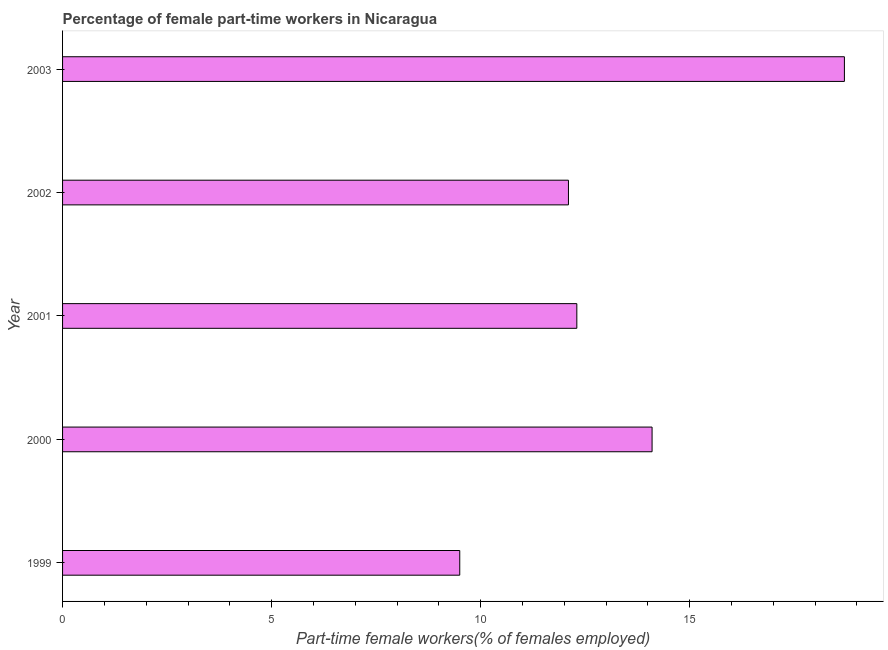Does the graph contain any zero values?
Your answer should be very brief. No. Does the graph contain grids?
Provide a succinct answer. No. What is the title of the graph?
Ensure brevity in your answer.  Percentage of female part-time workers in Nicaragua. What is the label or title of the X-axis?
Ensure brevity in your answer.  Part-time female workers(% of females employed). What is the label or title of the Y-axis?
Your answer should be compact. Year. What is the percentage of part-time female workers in 2000?
Your response must be concise. 14.1. Across all years, what is the maximum percentage of part-time female workers?
Offer a terse response. 18.7. Across all years, what is the minimum percentage of part-time female workers?
Your response must be concise. 9.5. What is the sum of the percentage of part-time female workers?
Offer a very short reply. 66.7. What is the difference between the percentage of part-time female workers in 1999 and 2002?
Your answer should be compact. -2.6. What is the average percentage of part-time female workers per year?
Ensure brevity in your answer.  13.34. What is the median percentage of part-time female workers?
Your answer should be very brief. 12.3. In how many years, is the percentage of part-time female workers greater than 8 %?
Your answer should be very brief. 5. Do a majority of the years between 1999 and 2001 (inclusive) have percentage of part-time female workers greater than 4 %?
Provide a short and direct response. Yes. What is the ratio of the percentage of part-time female workers in 2001 to that in 2003?
Give a very brief answer. 0.66. Is the difference between the percentage of part-time female workers in 2000 and 2003 greater than the difference between any two years?
Your answer should be very brief. No. What is the difference between the highest and the second highest percentage of part-time female workers?
Your response must be concise. 4.6. In how many years, is the percentage of part-time female workers greater than the average percentage of part-time female workers taken over all years?
Your response must be concise. 2. Are the values on the major ticks of X-axis written in scientific E-notation?
Keep it short and to the point. No. What is the Part-time female workers(% of females employed) of 1999?
Make the answer very short. 9.5. What is the Part-time female workers(% of females employed) in 2000?
Provide a succinct answer. 14.1. What is the Part-time female workers(% of females employed) in 2001?
Keep it short and to the point. 12.3. What is the Part-time female workers(% of females employed) of 2002?
Provide a succinct answer. 12.1. What is the Part-time female workers(% of females employed) of 2003?
Make the answer very short. 18.7. What is the difference between the Part-time female workers(% of females employed) in 1999 and 2001?
Offer a very short reply. -2.8. What is the difference between the Part-time female workers(% of females employed) in 1999 and 2002?
Your answer should be compact. -2.6. What is the difference between the Part-time female workers(% of females employed) in 2000 and 2001?
Give a very brief answer. 1.8. What is the difference between the Part-time female workers(% of females employed) in 2000 and 2003?
Ensure brevity in your answer.  -4.6. What is the difference between the Part-time female workers(% of females employed) in 2001 and 2002?
Your answer should be very brief. 0.2. What is the difference between the Part-time female workers(% of females employed) in 2001 and 2003?
Offer a terse response. -6.4. What is the difference between the Part-time female workers(% of females employed) in 2002 and 2003?
Offer a terse response. -6.6. What is the ratio of the Part-time female workers(% of females employed) in 1999 to that in 2000?
Provide a short and direct response. 0.67. What is the ratio of the Part-time female workers(% of females employed) in 1999 to that in 2001?
Offer a terse response. 0.77. What is the ratio of the Part-time female workers(% of females employed) in 1999 to that in 2002?
Keep it short and to the point. 0.79. What is the ratio of the Part-time female workers(% of females employed) in 1999 to that in 2003?
Your answer should be very brief. 0.51. What is the ratio of the Part-time female workers(% of females employed) in 2000 to that in 2001?
Make the answer very short. 1.15. What is the ratio of the Part-time female workers(% of females employed) in 2000 to that in 2002?
Your answer should be very brief. 1.17. What is the ratio of the Part-time female workers(% of females employed) in 2000 to that in 2003?
Offer a very short reply. 0.75. What is the ratio of the Part-time female workers(% of females employed) in 2001 to that in 2002?
Give a very brief answer. 1.02. What is the ratio of the Part-time female workers(% of females employed) in 2001 to that in 2003?
Your answer should be compact. 0.66. What is the ratio of the Part-time female workers(% of females employed) in 2002 to that in 2003?
Provide a short and direct response. 0.65. 